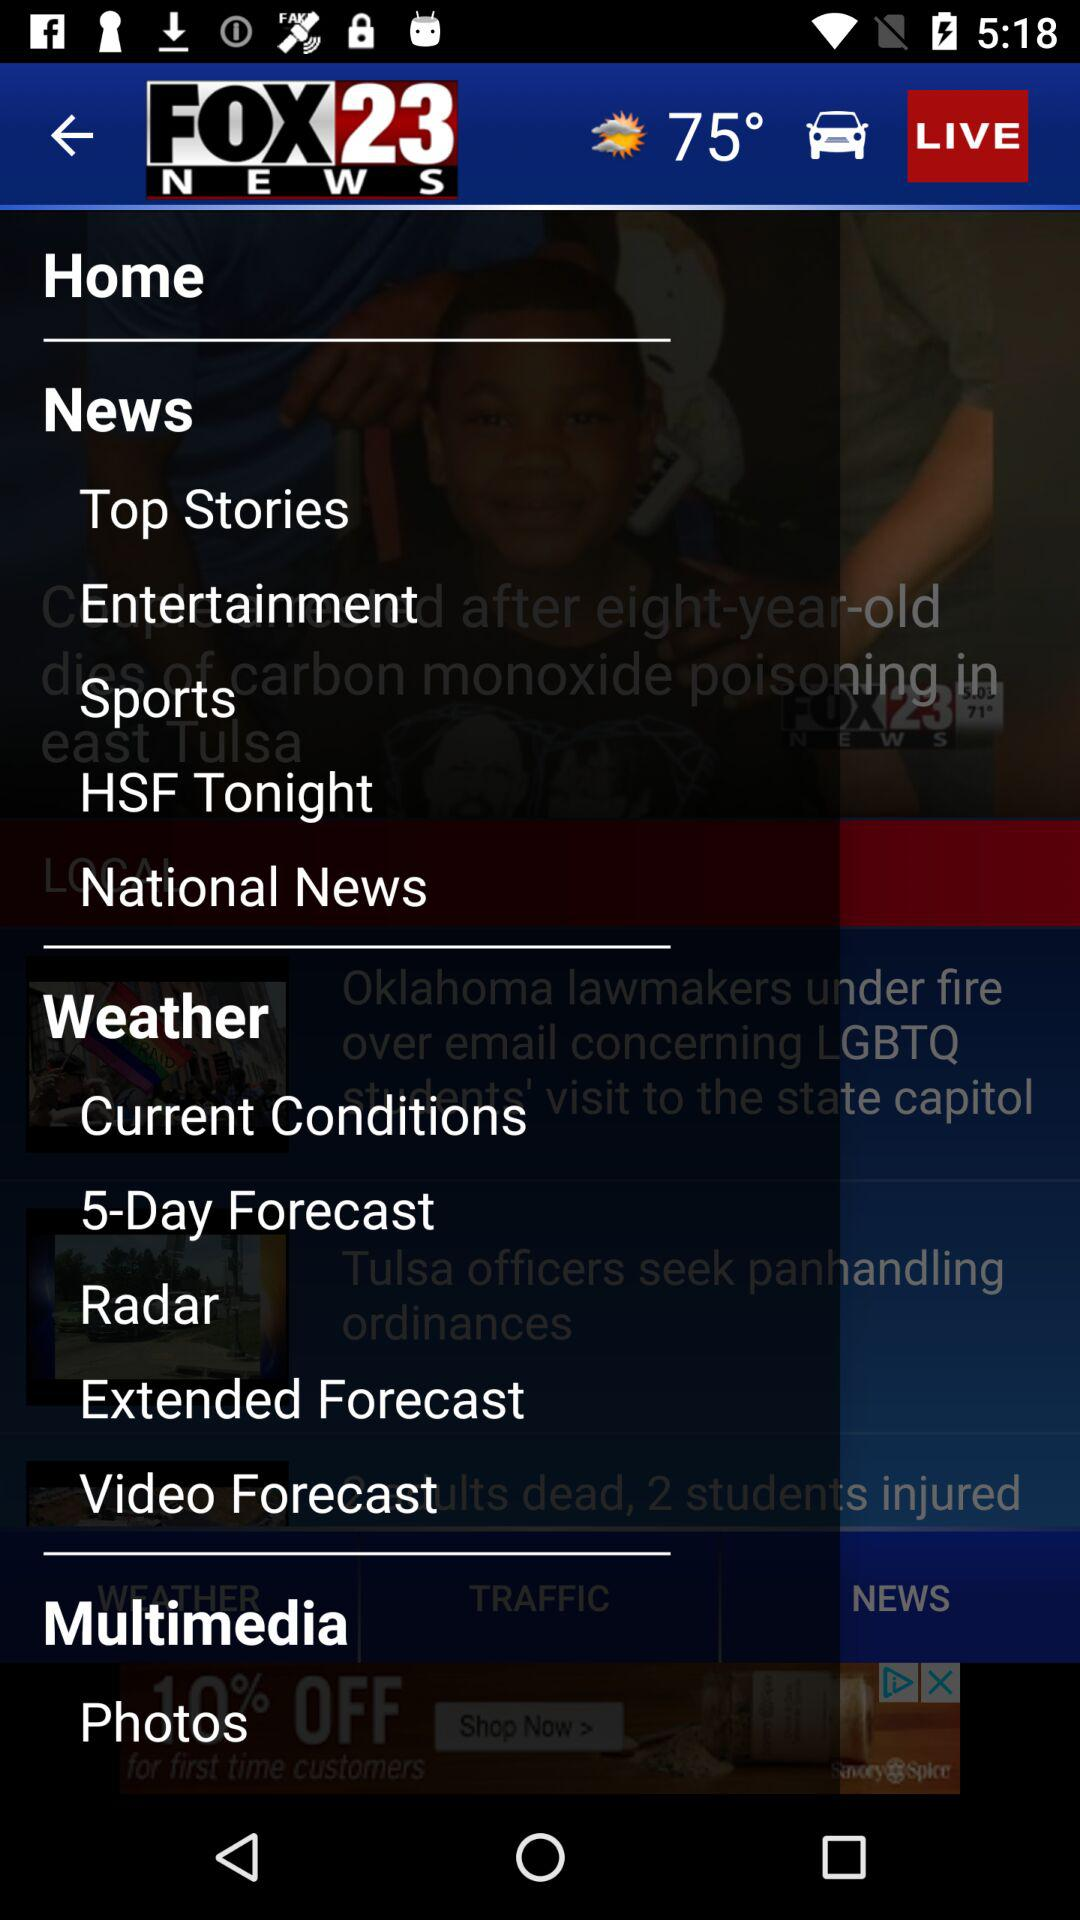What is the name of the application? The name of the application is "FOX23 NEWS". 